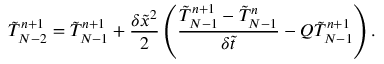<formula> <loc_0><loc_0><loc_500><loc_500>\tilde { T } _ { N - 2 } ^ { n + 1 } = \tilde { T } _ { N - 1 } ^ { n + 1 } + \frac { { \delta { { \tilde { x } } ^ { 2 } } } } { 2 } \left ( { \frac { { \tilde { T } _ { N - 1 } ^ { n + 1 } - \tilde { T } _ { N - 1 } ^ { n } } } { { \delta \tilde { t } } } - Q \tilde { T } _ { N - 1 } ^ { n + 1 } } \right ) .</formula> 